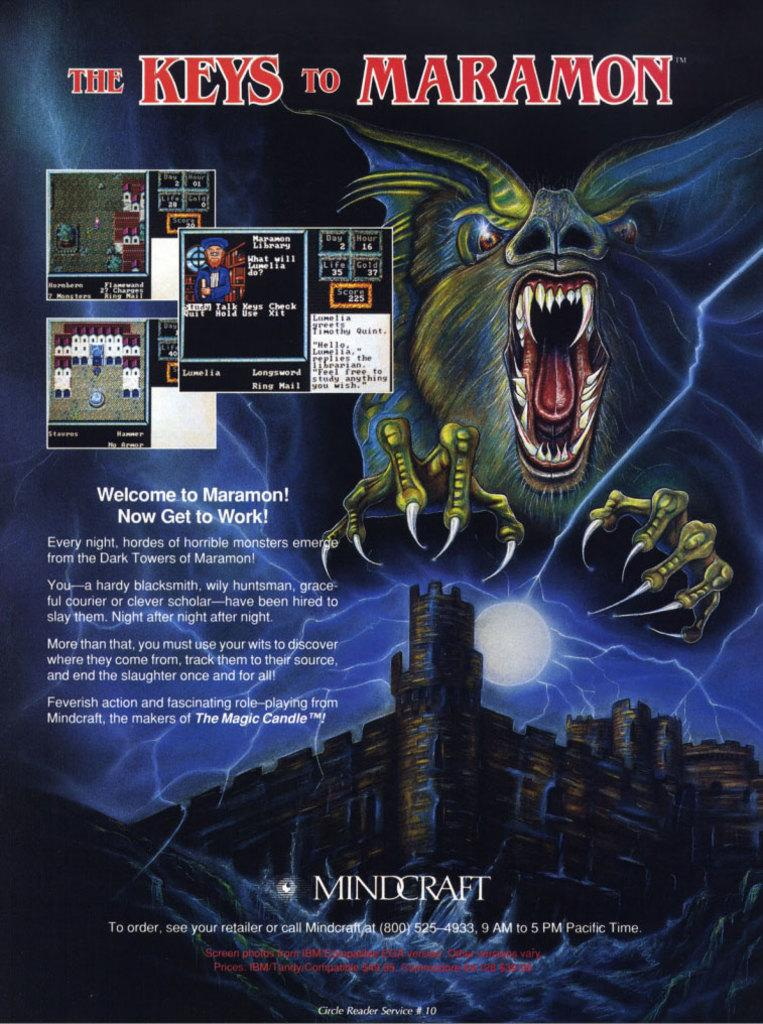<image>
Describe the image concisely. The back of a video game explains the game to the buyer. 